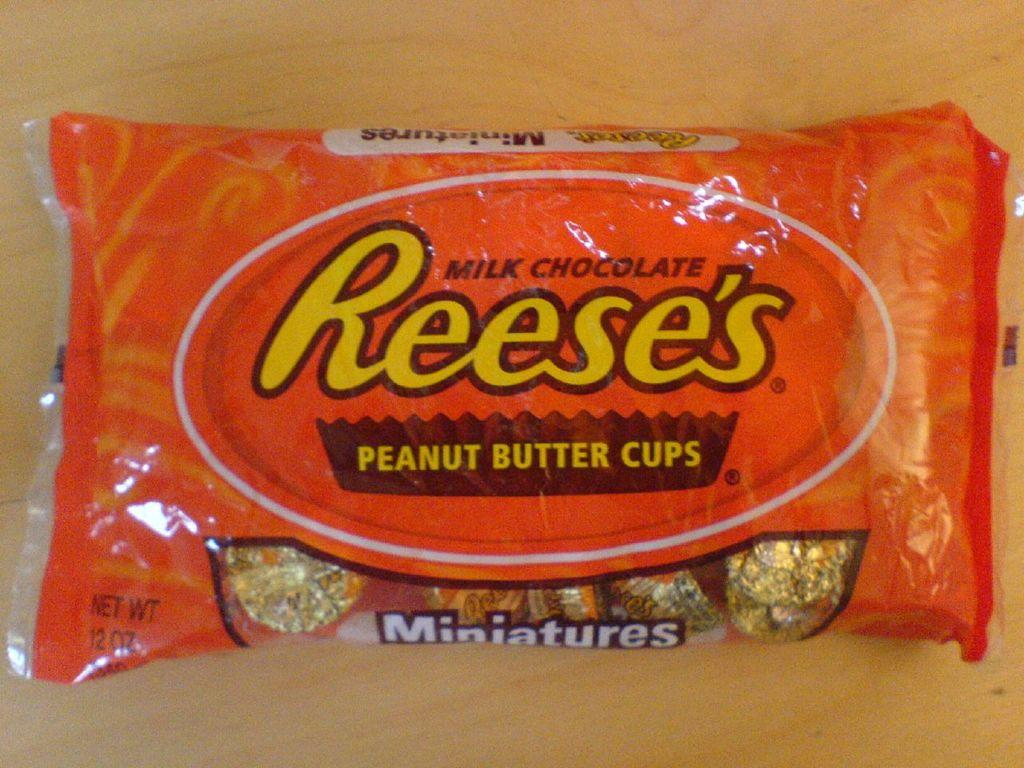What is the main object in the image? There is a food packet in the image. Where is the food packet located? The food packet is on a wooden surface. How many flowers are on the food packet in the image? There are no flowers present on the food packet in the image. 